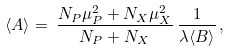<formula> <loc_0><loc_0><loc_500><loc_500>\langle A \rangle = \, \frac { N _ { P } \mu _ { P } ^ { 2 } + N _ { X } \mu _ { X } ^ { 2 } } { N _ { P } + N _ { X } } \, \frac { 1 } { \lambda \langle B \rangle } \, ,</formula> 